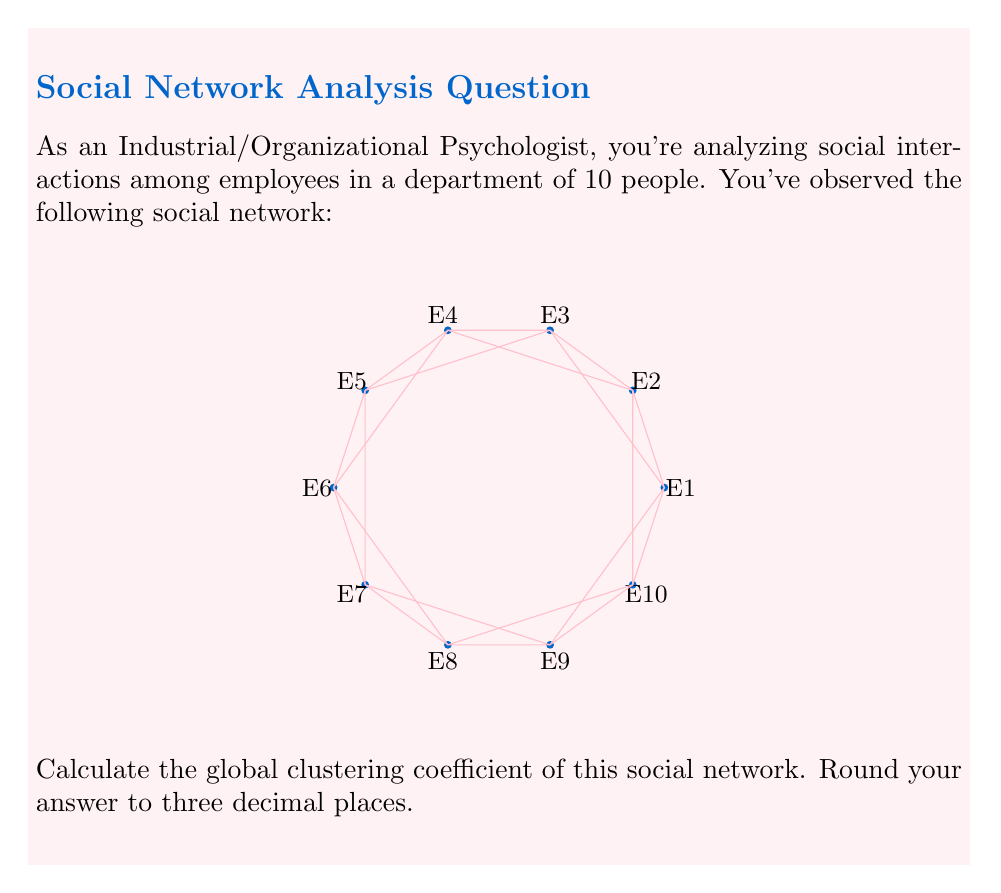Help me with this question. To solve this problem, we'll follow these steps:

1) The global clustering coefficient $C$ is defined as:

   $$C = \frac{3 \times \text{number of triangles}}{\text{number of connected triples}}$$

2) First, let's count the number of triangles in the network:
   - There are 10 triangles formed by adjacent employees (e.g., E1-E2-E3, E2-E3-E4, etc.)
   - There are 5 triangles formed by every other employee (e.g., E1-E3-E5, E2-E4-E6, etc.)
   Total number of triangles = 10 + 5 = 15

3) Now, let's count the number of connected triples:
   - Each employee is connected to 4 others, forming 4 triples
   - Total number of triples = 10 employees × 4 triples = 40

4) Applying the formula:

   $$C = \frac{3 \times 15}{40} = \frac{45}{40} = 1.125$$

5) Rounding to three decimal places: 1.125
Answer: 1.125 